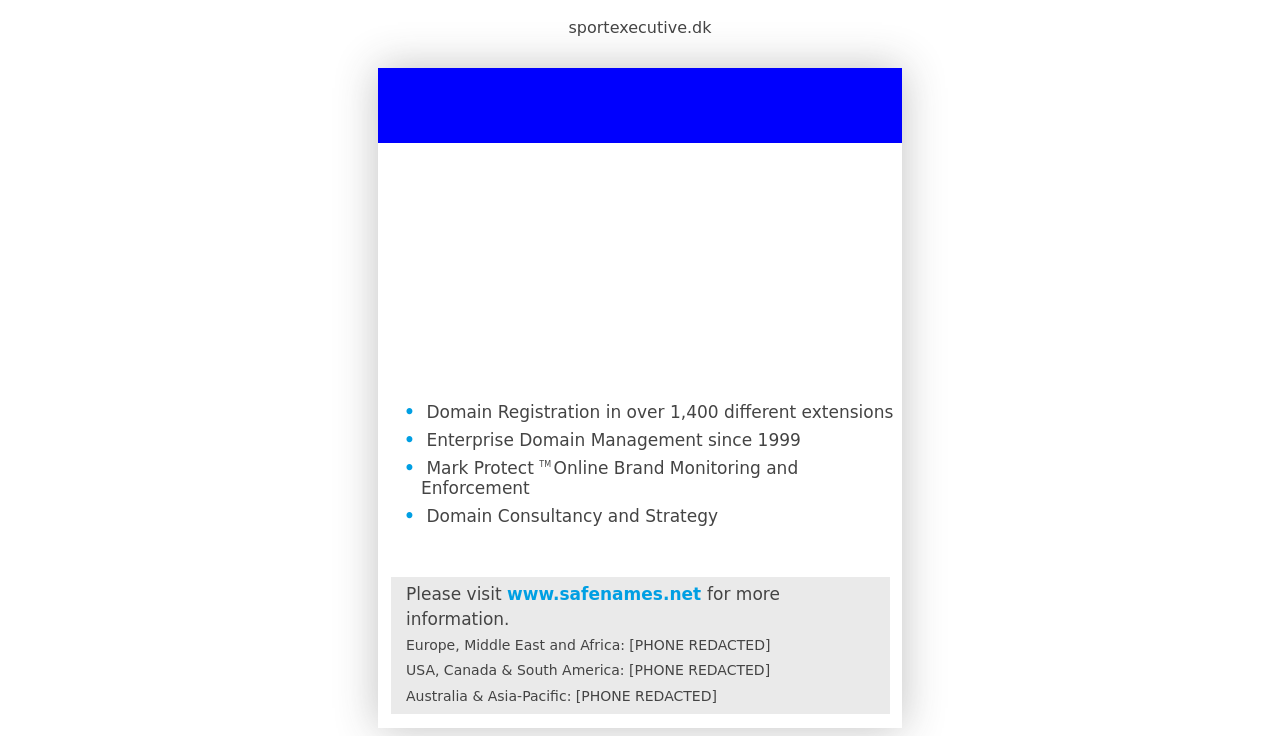What's the procedure for constructing this website from scratch with HTML? To construct a website similar to the one shown in the image from scratch using HTML, you'll need to follow these steps:
1. **Setup the Basic HTML Structure**: Begin by defining the DOCTYPE and creating the HTML, Head, and Body tags.
2. **Add Meta Tags and CSS Links in the Head**: Include meta tags for responsiveness and link external CSS for styling.
3. **Structure Your Content with Semantic HTML**: Use proper tags like header, section, footer for the layout. For content similar to the image, you would create a header for logos, a main section for key services, and a footer for contact information.
4. **Style with CSS**: Define the CSS styles for layout, color schemes, fonts, and more, similar to the CSS provided in the original response but adjusted to match your specific design requirements.
5. **Test and Validate**: Ensure the code is valid against HTML standards and check the responsiveness on different devices. Optionally, use JavaScript to add interactivity.
6. **Launch**: Upload your files to a server to make your site live.
This will create a foundational website which you can continue to develop and enhance based on further requirements. 